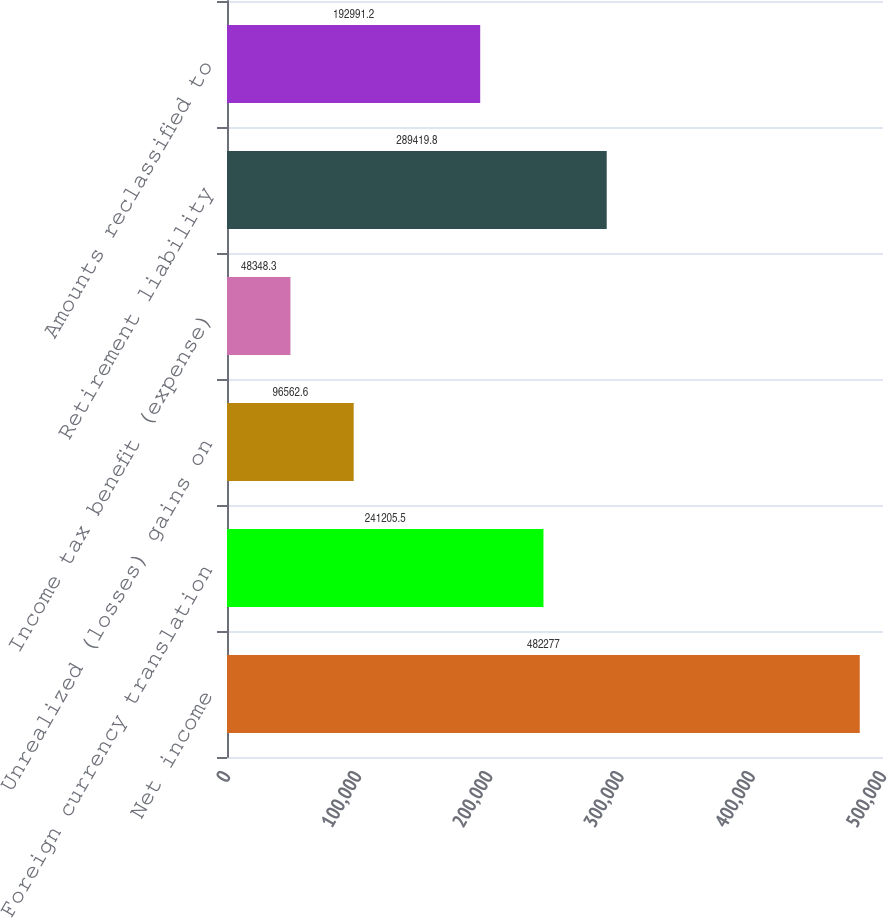Convert chart. <chart><loc_0><loc_0><loc_500><loc_500><bar_chart><fcel>Net income<fcel>Foreign currency translation<fcel>Unrealized (losses) gains on<fcel>Income tax benefit (expense)<fcel>Retirement liability<fcel>Amounts reclassified to<nl><fcel>482277<fcel>241206<fcel>96562.6<fcel>48348.3<fcel>289420<fcel>192991<nl></chart> 